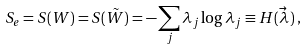<formula> <loc_0><loc_0><loc_500><loc_500>S _ { e } = S ( W ) = S ( \tilde { W } ) = - \sum _ { j } \lambda _ { j } \log \lambda _ { j } \equiv H ( \vec { \lambda } \, ) \, ,</formula> 